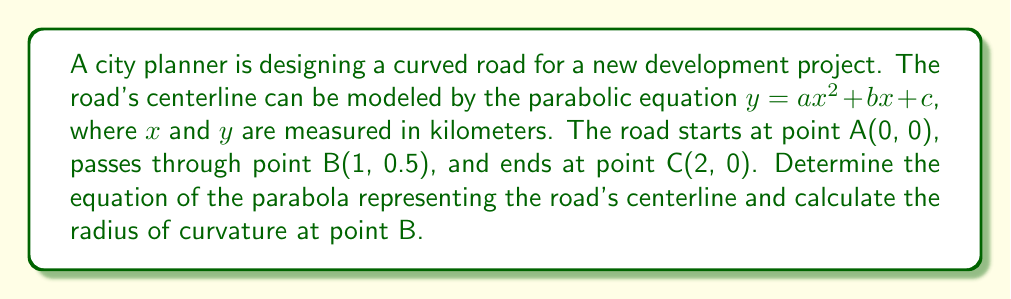Can you solve this math problem? To solve this problem, we'll follow these steps:

1) First, let's find the equation of the parabola using the given points:

   Point A: (0, 0) → $c = 0$
   Point B: (1, 0.5)
   Point C: (2, 0)

   Substituting these points into the general equation $y = ax^2 + bx + c$:

   For B: $0.5 = a(1)^2 + b(1) + 0$
   For C: $0 = a(2)^2 + b(2) + 0$

2) We now have two equations:
   $0.5 = a + b$ (Equation 1)
   $0 = 4a + 2b$ (Equation 2)

3) Multiply Equation 1 by 2:
   $1 = 2a + 2b$ (Equation 3)

4) Subtract Equation 2 from Equation 3:
   $1 = -2a$
   $a = -0.5$

5) Substitute this value of $a$ into Equation 1:
   $0.5 = -0.5 + b$
   $b = 1$

6) Therefore, the equation of the parabola is:
   $y = -0.5x^2 + x$

7) To find the radius of curvature at point B(1, 0.5), we use the formula:

   $R = \frac{[1 + (y')^2]^{3/2}}{|y''|}$

   Where $y'$ is the first derivative and $y''$ is the second derivative of the parabola equation.

8) Calculate derivatives:
   $y' = -x + 1$
   $y'' = -1$

9) At point B(1, 0.5):
   $y'(1) = -1 + 1 = 0$
   $y''(1) = -1$

10) Substitute into the radius of curvature formula:

    $R = \frac{[1 + (0)^2]^{3/2}}{|-1|} = 1$ km
Answer: The equation of the parabola representing the road's centerline is $y = -0.5x^2 + x$, and the radius of curvature at point B is 1 km. 